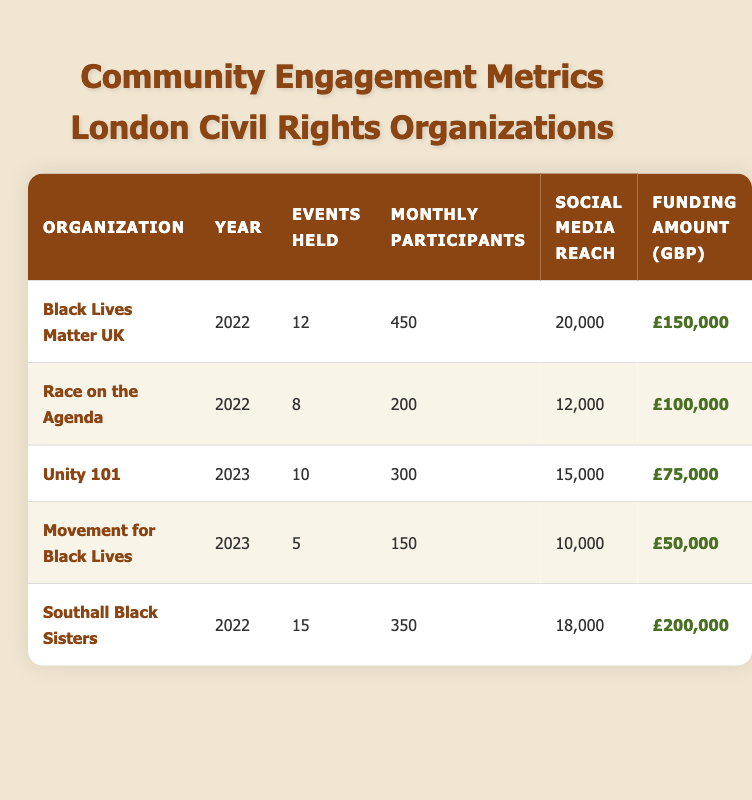What organization had the highest funding amount in 2022? Southall Black Sisters had a funding amount of £200,000 in 2022, which is the highest compared to other organizations listed.
Answer: £200,000 How many events did Black Lives Matter UK hold in 2022? According to the table, Black Lives Matter UK held 12 events in 2022.
Answer: 12 What is the total number of monthly participants across all organizations in 2022? The organizations in 2022 are Black Lives Matter UK with 450 participants, Race on the Agenda with 200, and Southall Black Sisters with 350. Adding these gives: 450 + 200 + 350 = 1000 monthly participants.
Answer: 1000 Did Movement for Black Lives have more events than Unity 101 in 2023? Movement for Black Lives held 5 events while Unity 101 held 10 events in 2023. Therefore, Movement for Black Lives did not have more events than Unity 101.
Answer: No What was the average social media reach for all organizations listed in 2022? The social media reach for the organizations in 2022 is 20,000 for Black Lives Matter UK, 12,000 for Race on the Agenda, and 18,000 for Southall Black Sisters. The average is calculated by summing these values (20,000 + 12,000 + 18,000 = 50,000) and dividing by the number of organizations (3), resulting in an average of 50,000 / 3 ≈ 16,667.
Answer: 16,667 Which organization had the least number of monthly participants in the data? Movement for Black Lives had the least number of monthly participants with 150 in 2023, compared to the others.
Answer: 150 How many more events did Southall Black Sisters hold compared to Race on the Agenda in 2022? Southall Black Sisters held 15 events in 2022, while Race on the Agenda held 8 events. Therefore, the difference is 15 - 8 = 7 more events.
Answer: 7 What was the total funding amount for the organizations listed in 2023? Unity 101 received £75,000 and Movement for Black Lives received £50,000 in 2023. The total funding is £75,000 + £50,000 = £125,000.
Answer: £125,000 